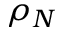<formula> <loc_0><loc_0><loc_500><loc_500>\rho _ { N }</formula> 